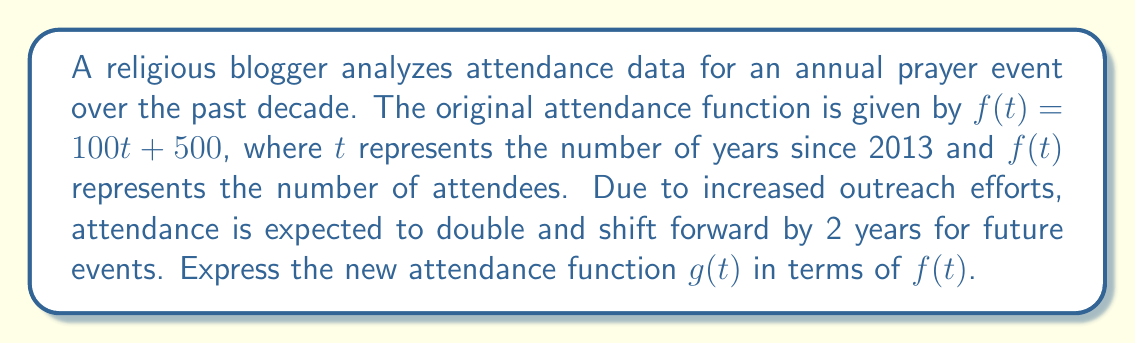Teach me how to tackle this problem. To find the new attendance function $g(t)$, we need to apply scaling and translation transformations to the original function $f(t)$. Let's break this down step-by-step:

1. Double the attendance (vertical stretch):
   The attendance is expected to double, which means we need to multiply $f(t)$ by 2.
   $g_1(t) = 2f(t)$

2. Shift forward by 2 years (horizontal shift):
   A forward shift of 2 years means we replace $t$ with $(t-2)$ in the function.
   $g(t) = 2f(t-2)$

3. Expressing $g(t)$ in terms of $f(t)$:
   The final transformed function is:
   $g(t) = 2f(t-2)$

This new function $g(t)$ represents the doubled attendance shifted forward by 2 years.
Answer: $g(t) = 2f(t-2)$ 